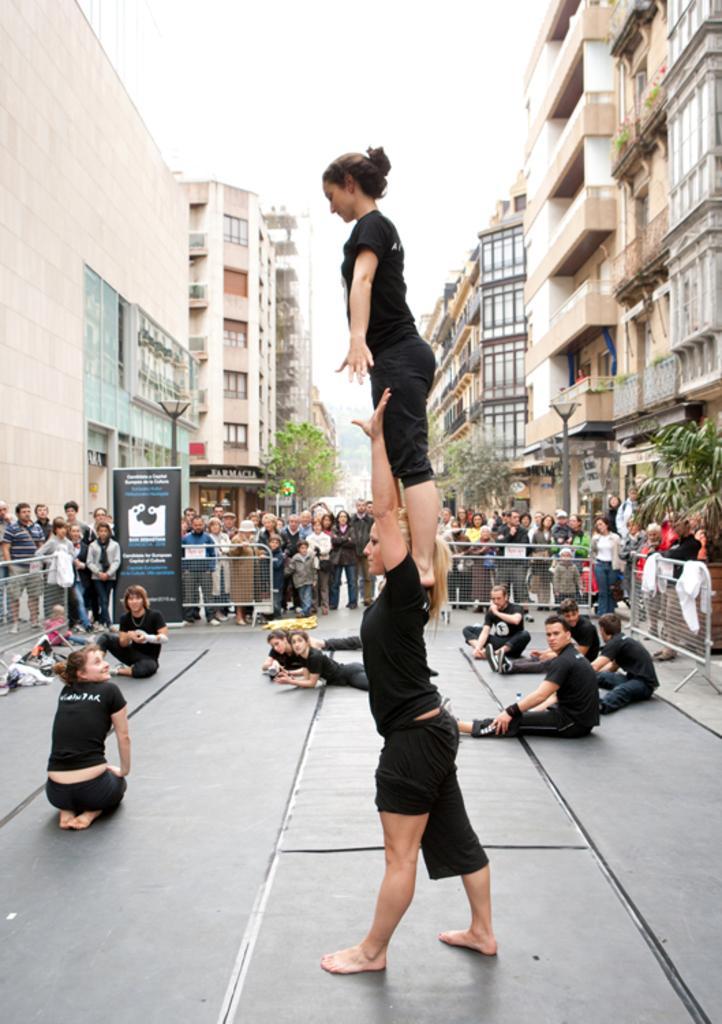Please provide a concise description of this image. In this image I can see there are few persons standing and few persons sitting on the ground. And there is a fence. And at the back there are buildings and a light pole and there is a cloth. And there are trees. And at the top there is a sky. 